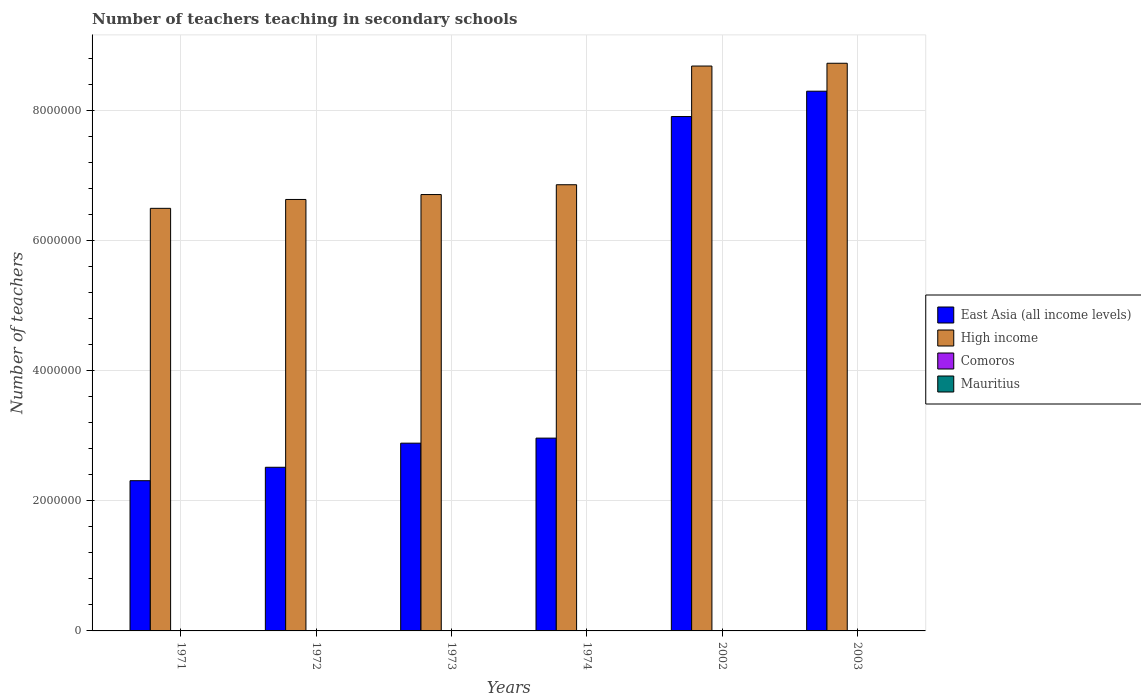How many different coloured bars are there?
Provide a succinct answer. 4. Are the number of bars per tick equal to the number of legend labels?
Give a very brief answer. Yes. Are the number of bars on each tick of the X-axis equal?
Offer a very short reply. Yes. How many bars are there on the 5th tick from the left?
Your answer should be compact. 4. How many bars are there on the 4th tick from the right?
Offer a terse response. 4. In how many cases, is the number of bars for a given year not equal to the number of legend labels?
Your response must be concise. 0. What is the number of teachers teaching in secondary schools in High income in 2002?
Give a very brief answer. 8.68e+06. Across all years, what is the maximum number of teachers teaching in secondary schools in East Asia (all income levels)?
Provide a short and direct response. 8.30e+06. Across all years, what is the minimum number of teachers teaching in secondary schools in High income?
Offer a very short reply. 6.49e+06. In which year was the number of teachers teaching in secondary schools in Comoros maximum?
Provide a succinct answer. 2003. In which year was the number of teachers teaching in secondary schools in East Asia (all income levels) minimum?
Keep it short and to the point. 1971. What is the total number of teachers teaching in secondary schools in Comoros in the graph?
Keep it short and to the point. 6367. What is the difference between the number of teachers teaching in secondary schools in Comoros in 1973 and that in 2002?
Offer a very short reply. -2485. What is the difference between the number of teachers teaching in secondary schools in High income in 1974 and the number of teachers teaching in secondary schools in Comoros in 2002?
Offer a very short reply. 6.85e+06. What is the average number of teachers teaching in secondary schools in High income per year?
Your answer should be compact. 7.35e+06. In the year 2002, what is the difference between the number of teachers teaching in secondary schools in East Asia (all income levels) and number of teachers teaching in secondary schools in High income?
Offer a very short reply. -7.76e+05. In how many years, is the number of teachers teaching in secondary schools in Mauritius greater than 2000000?
Provide a succinct answer. 0. What is the ratio of the number of teachers teaching in secondary schools in High income in 1972 to that in 1973?
Provide a succinct answer. 0.99. What is the difference between the highest and the second highest number of teachers teaching in secondary schools in East Asia (all income levels)?
Your answer should be very brief. 3.90e+05. What is the difference between the highest and the lowest number of teachers teaching in secondary schools in High income?
Offer a terse response. 2.23e+06. Is the sum of the number of teachers teaching in secondary schools in East Asia (all income levels) in 1972 and 2002 greater than the maximum number of teachers teaching in secondary schools in Mauritius across all years?
Give a very brief answer. Yes. What does the 2nd bar from the left in 1973 represents?
Ensure brevity in your answer.  High income. What does the 1st bar from the right in 2003 represents?
Keep it short and to the point. Mauritius. Is it the case that in every year, the sum of the number of teachers teaching in secondary schools in Mauritius and number of teachers teaching in secondary schools in High income is greater than the number of teachers teaching in secondary schools in East Asia (all income levels)?
Provide a succinct answer. Yes. Are all the bars in the graph horizontal?
Keep it short and to the point. No. How many years are there in the graph?
Give a very brief answer. 6. What is the difference between two consecutive major ticks on the Y-axis?
Give a very brief answer. 2.00e+06. Are the values on the major ticks of Y-axis written in scientific E-notation?
Give a very brief answer. No. Where does the legend appear in the graph?
Provide a short and direct response. Center right. How many legend labels are there?
Your answer should be compact. 4. What is the title of the graph?
Keep it short and to the point. Number of teachers teaching in secondary schools. What is the label or title of the X-axis?
Make the answer very short. Years. What is the label or title of the Y-axis?
Your answer should be compact. Number of teachers. What is the Number of teachers in East Asia (all income levels) in 1971?
Give a very brief answer. 2.31e+06. What is the Number of teachers in High income in 1971?
Your answer should be very brief. 6.49e+06. What is the Number of teachers in Comoros in 1971?
Keep it short and to the point. 63. What is the Number of teachers in Mauritius in 1971?
Offer a terse response. 1890. What is the Number of teachers in East Asia (all income levels) in 1972?
Provide a short and direct response. 2.52e+06. What is the Number of teachers in High income in 1972?
Your response must be concise. 6.63e+06. What is the Number of teachers of Comoros in 1972?
Make the answer very short. 66. What is the Number of teachers in Mauritius in 1972?
Your answer should be very brief. 1856. What is the Number of teachers in East Asia (all income levels) in 1973?
Your answer should be very brief. 2.89e+06. What is the Number of teachers in High income in 1973?
Make the answer very short. 6.71e+06. What is the Number of teachers of Comoros in 1973?
Offer a terse response. 113. What is the Number of teachers of Mauritius in 1973?
Your answer should be compact. 1990. What is the Number of teachers in East Asia (all income levels) in 1974?
Keep it short and to the point. 2.96e+06. What is the Number of teachers in High income in 1974?
Provide a succinct answer. 6.86e+06. What is the Number of teachers in Comoros in 1974?
Offer a very short reply. 128. What is the Number of teachers in Mauritius in 1974?
Offer a terse response. 2027. What is the Number of teachers in East Asia (all income levels) in 2002?
Offer a terse response. 7.91e+06. What is the Number of teachers in High income in 2002?
Give a very brief answer. 8.68e+06. What is the Number of teachers in Comoros in 2002?
Make the answer very short. 2598. What is the Number of teachers of Mauritius in 2002?
Give a very brief answer. 5933. What is the Number of teachers in East Asia (all income levels) in 2003?
Provide a short and direct response. 8.30e+06. What is the Number of teachers in High income in 2003?
Keep it short and to the point. 8.72e+06. What is the Number of teachers in Comoros in 2003?
Offer a terse response. 3399. What is the Number of teachers of Mauritius in 2003?
Provide a short and direct response. 6371. Across all years, what is the maximum Number of teachers of East Asia (all income levels)?
Give a very brief answer. 8.30e+06. Across all years, what is the maximum Number of teachers of High income?
Your answer should be compact. 8.72e+06. Across all years, what is the maximum Number of teachers in Comoros?
Offer a very short reply. 3399. Across all years, what is the maximum Number of teachers of Mauritius?
Offer a terse response. 6371. Across all years, what is the minimum Number of teachers of East Asia (all income levels)?
Offer a very short reply. 2.31e+06. Across all years, what is the minimum Number of teachers of High income?
Ensure brevity in your answer.  6.49e+06. Across all years, what is the minimum Number of teachers of Comoros?
Give a very brief answer. 63. Across all years, what is the minimum Number of teachers in Mauritius?
Your answer should be very brief. 1856. What is the total Number of teachers of East Asia (all income levels) in the graph?
Keep it short and to the point. 2.69e+07. What is the total Number of teachers in High income in the graph?
Ensure brevity in your answer.  4.41e+07. What is the total Number of teachers in Comoros in the graph?
Your response must be concise. 6367. What is the total Number of teachers of Mauritius in the graph?
Your response must be concise. 2.01e+04. What is the difference between the Number of teachers of East Asia (all income levels) in 1971 and that in 1972?
Your answer should be compact. -2.06e+05. What is the difference between the Number of teachers of High income in 1971 and that in 1972?
Offer a terse response. -1.37e+05. What is the difference between the Number of teachers of Mauritius in 1971 and that in 1972?
Ensure brevity in your answer.  34. What is the difference between the Number of teachers of East Asia (all income levels) in 1971 and that in 1973?
Ensure brevity in your answer.  -5.77e+05. What is the difference between the Number of teachers of High income in 1971 and that in 1973?
Offer a very short reply. -2.12e+05. What is the difference between the Number of teachers in Comoros in 1971 and that in 1973?
Your answer should be compact. -50. What is the difference between the Number of teachers of Mauritius in 1971 and that in 1973?
Offer a terse response. -100. What is the difference between the Number of teachers in East Asia (all income levels) in 1971 and that in 1974?
Provide a succinct answer. -6.54e+05. What is the difference between the Number of teachers of High income in 1971 and that in 1974?
Give a very brief answer. -3.63e+05. What is the difference between the Number of teachers of Comoros in 1971 and that in 1974?
Provide a short and direct response. -65. What is the difference between the Number of teachers in Mauritius in 1971 and that in 1974?
Your answer should be compact. -137. What is the difference between the Number of teachers of East Asia (all income levels) in 1971 and that in 2002?
Your response must be concise. -5.60e+06. What is the difference between the Number of teachers in High income in 1971 and that in 2002?
Your answer should be compact. -2.19e+06. What is the difference between the Number of teachers of Comoros in 1971 and that in 2002?
Ensure brevity in your answer.  -2535. What is the difference between the Number of teachers in Mauritius in 1971 and that in 2002?
Ensure brevity in your answer.  -4043. What is the difference between the Number of teachers of East Asia (all income levels) in 1971 and that in 2003?
Provide a short and direct response. -5.99e+06. What is the difference between the Number of teachers in High income in 1971 and that in 2003?
Provide a succinct answer. -2.23e+06. What is the difference between the Number of teachers in Comoros in 1971 and that in 2003?
Offer a very short reply. -3336. What is the difference between the Number of teachers in Mauritius in 1971 and that in 2003?
Offer a very short reply. -4481. What is the difference between the Number of teachers of East Asia (all income levels) in 1972 and that in 1973?
Your answer should be compact. -3.71e+05. What is the difference between the Number of teachers of High income in 1972 and that in 1973?
Offer a very short reply. -7.53e+04. What is the difference between the Number of teachers of Comoros in 1972 and that in 1973?
Provide a succinct answer. -47. What is the difference between the Number of teachers of Mauritius in 1972 and that in 1973?
Offer a very short reply. -134. What is the difference between the Number of teachers in East Asia (all income levels) in 1972 and that in 1974?
Provide a short and direct response. -4.48e+05. What is the difference between the Number of teachers of High income in 1972 and that in 1974?
Your response must be concise. -2.26e+05. What is the difference between the Number of teachers of Comoros in 1972 and that in 1974?
Your response must be concise. -62. What is the difference between the Number of teachers in Mauritius in 1972 and that in 1974?
Keep it short and to the point. -171. What is the difference between the Number of teachers in East Asia (all income levels) in 1972 and that in 2002?
Offer a terse response. -5.39e+06. What is the difference between the Number of teachers in High income in 1972 and that in 2002?
Make the answer very short. -2.05e+06. What is the difference between the Number of teachers in Comoros in 1972 and that in 2002?
Your answer should be compact. -2532. What is the difference between the Number of teachers of Mauritius in 1972 and that in 2002?
Your answer should be compact. -4077. What is the difference between the Number of teachers of East Asia (all income levels) in 1972 and that in 2003?
Provide a succinct answer. -5.78e+06. What is the difference between the Number of teachers in High income in 1972 and that in 2003?
Your answer should be compact. -2.09e+06. What is the difference between the Number of teachers of Comoros in 1972 and that in 2003?
Your response must be concise. -3333. What is the difference between the Number of teachers of Mauritius in 1972 and that in 2003?
Offer a very short reply. -4515. What is the difference between the Number of teachers of East Asia (all income levels) in 1973 and that in 1974?
Provide a succinct answer. -7.75e+04. What is the difference between the Number of teachers in High income in 1973 and that in 1974?
Give a very brief answer. -1.51e+05. What is the difference between the Number of teachers of Mauritius in 1973 and that in 1974?
Provide a succinct answer. -37. What is the difference between the Number of teachers in East Asia (all income levels) in 1973 and that in 2002?
Your answer should be compact. -5.02e+06. What is the difference between the Number of teachers in High income in 1973 and that in 2002?
Keep it short and to the point. -1.98e+06. What is the difference between the Number of teachers in Comoros in 1973 and that in 2002?
Offer a very short reply. -2485. What is the difference between the Number of teachers in Mauritius in 1973 and that in 2002?
Offer a very short reply. -3943. What is the difference between the Number of teachers in East Asia (all income levels) in 1973 and that in 2003?
Your response must be concise. -5.41e+06. What is the difference between the Number of teachers in High income in 1973 and that in 2003?
Provide a short and direct response. -2.02e+06. What is the difference between the Number of teachers of Comoros in 1973 and that in 2003?
Offer a terse response. -3286. What is the difference between the Number of teachers in Mauritius in 1973 and that in 2003?
Make the answer very short. -4381. What is the difference between the Number of teachers of East Asia (all income levels) in 1974 and that in 2002?
Offer a very short reply. -4.94e+06. What is the difference between the Number of teachers in High income in 1974 and that in 2002?
Your response must be concise. -1.82e+06. What is the difference between the Number of teachers of Comoros in 1974 and that in 2002?
Give a very brief answer. -2470. What is the difference between the Number of teachers in Mauritius in 1974 and that in 2002?
Make the answer very short. -3906. What is the difference between the Number of teachers of East Asia (all income levels) in 1974 and that in 2003?
Give a very brief answer. -5.33e+06. What is the difference between the Number of teachers in High income in 1974 and that in 2003?
Offer a terse response. -1.87e+06. What is the difference between the Number of teachers of Comoros in 1974 and that in 2003?
Ensure brevity in your answer.  -3271. What is the difference between the Number of teachers of Mauritius in 1974 and that in 2003?
Your answer should be compact. -4344. What is the difference between the Number of teachers of East Asia (all income levels) in 2002 and that in 2003?
Offer a terse response. -3.90e+05. What is the difference between the Number of teachers in High income in 2002 and that in 2003?
Give a very brief answer. -4.28e+04. What is the difference between the Number of teachers in Comoros in 2002 and that in 2003?
Your response must be concise. -801. What is the difference between the Number of teachers of Mauritius in 2002 and that in 2003?
Make the answer very short. -438. What is the difference between the Number of teachers of East Asia (all income levels) in 1971 and the Number of teachers of High income in 1972?
Provide a short and direct response. -4.32e+06. What is the difference between the Number of teachers in East Asia (all income levels) in 1971 and the Number of teachers in Comoros in 1972?
Your response must be concise. 2.31e+06. What is the difference between the Number of teachers of East Asia (all income levels) in 1971 and the Number of teachers of Mauritius in 1972?
Ensure brevity in your answer.  2.31e+06. What is the difference between the Number of teachers of High income in 1971 and the Number of teachers of Comoros in 1972?
Your answer should be very brief. 6.49e+06. What is the difference between the Number of teachers in High income in 1971 and the Number of teachers in Mauritius in 1972?
Your answer should be very brief. 6.49e+06. What is the difference between the Number of teachers of Comoros in 1971 and the Number of teachers of Mauritius in 1972?
Your response must be concise. -1793. What is the difference between the Number of teachers of East Asia (all income levels) in 1971 and the Number of teachers of High income in 1973?
Your answer should be very brief. -4.40e+06. What is the difference between the Number of teachers of East Asia (all income levels) in 1971 and the Number of teachers of Comoros in 1973?
Your response must be concise. 2.31e+06. What is the difference between the Number of teachers of East Asia (all income levels) in 1971 and the Number of teachers of Mauritius in 1973?
Give a very brief answer. 2.31e+06. What is the difference between the Number of teachers of High income in 1971 and the Number of teachers of Comoros in 1973?
Your answer should be very brief. 6.49e+06. What is the difference between the Number of teachers of High income in 1971 and the Number of teachers of Mauritius in 1973?
Offer a terse response. 6.49e+06. What is the difference between the Number of teachers of Comoros in 1971 and the Number of teachers of Mauritius in 1973?
Ensure brevity in your answer.  -1927. What is the difference between the Number of teachers of East Asia (all income levels) in 1971 and the Number of teachers of High income in 1974?
Your response must be concise. -4.55e+06. What is the difference between the Number of teachers of East Asia (all income levels) in 1971 and the Number of teachers of Comoros in 1974?
Provide a short and direct response. 2.31e+06. What is the difference between the Number of teachers of East Asia (all income levels) in 1971 and the Number of teachers of Mauritius in 1974?
Your answer should be compact. 2.31e+06. What is the difference between the Number of teachers in High income in 1971 and the Number of teachers in Comoros in 1974?
Your answer should be compact. 6.49e+06. What is the difference between the Number of teachers in High income in 1971 and the Number of teachers in Mauritius in 1974?
Make the answer very short. 6.49e+06. What is the difference between the Number of teachers in Comoros in 1971 and the Number of teachers in Mauritius in 1974?
Give a very brief answer. -1964. What is the difference between the Number of teachers of East Asia (all income levels) in 1971 and the Number of teachers of High income in 2002?
Ensure brevity in your answer.  -6.37e+06. What is the difference between the Number of teachers of East Asia (all income levels) in 1971 and the Number of teachers of Comoros in 2002?
Offer a terse response. 2.31e+06. What is the difference between the Number of teachers in East Asia (all income levels) in 1971 and the Number of teachers in Mauritius in 2002?
Keep it short and to the point. 2.30e+06. What is the difference between the Number of teachers in High income in 1971 and the Number of teachers in Comoros in 2002?
Your response must be concise. 6.49e+06. What is the difference between the Number of teachers in High income in 1971 and the Number of teachers in Mauritius in 2002?
Ensure brevity in your answer.  6.49e+06. What is the difference between the Number of teachers in Comoros in 1971 and the Number of teachers in Mauritius in 2002?
Keep it short and to the point. -5870. What is the difference between the Number of teachers of East Asia (all income levels) in 1971 and the Number of teachers of High income in 2003?
Provide a short and direct response. -6.42e+06. What is the difference between the Number of teachers in East Asia (all income levels) in 1971 and the Number of teachers in Comoros in 2003?
Provide a short and direct response. 2.31e+06. What is the difference between the Number of teachers in East Asia (all income levels) in 1971 and the Number of teachers in Mauritius in 2003?
Ensure brevity in your answer.  2.30e+06. What is the difference between the Number of teachers in High income in 1971 and the Number of teachers in Comoros in 2003?
Ensure brevity in your answer.  6.49e+06. What is the difference between the Number of teachers in High income in 1971 and the Number of teachers in Mauritius in 2003?
Offer a terse response. 6.49e+06. What is the difference between the Number of teachers in Comoros in 1971 and the Number of teachers in Mauritius in 2003?
Your answer should be compact. -6308. What is the difference between the Number of teachers of East Asia (all income levels) in 1972 and the Number of teachers of High income in 1973?
Your answer should be compact. -4.19e+06. What is the difference between the Number of teachers in East Asia (all income levels) in 1972 and the Number of teachers in Comoros in 1973?
Keep it short and to the point. 2.51e+06. What is the difference between the Number of teachers in East Asia (all income levels) in 1972 and the Number of teachers in Mauritius in 1973?
Keep it short and to the point. 2.51e+06. What is the difference between the Number of teachers of High income in 1972 and the Number of teachers of Comoros in 1973?
Provide a short and direct response. 6.63e+06. What is the difference between the Number of teachers of High income in 1972 and the Number of teachers of Mauritius in 1973?
Your answer should be very brief. 6.63e+06. What is the difference between the Number of teachers of Comoros in 1972 and the Number of teachers of Mauritius in 1973?
Your answer should be very brief. -1924. What is the difference between the Number of teachers in East Asia (all income levels) in 1972 and the Number of teachers in High income in 1974?
Keep it short and to the point. -4.34e+06. What is the difference between the Number of teachers of East Asia (all income levels) in 1972 and the Number of teachers of Comoros in 1974?
Provide a short and direct response. 2.51e+06. What is the difference between the Number of teachers of East Asia (all income levels) in 1972 and the Number of teachers of Mauritius in 1974?
Provide a short and direct response. 2.51e+06. What is the difference between the Number of teachers of High income in 1972 and the Number of teachers of Comoros in 1974?
Give a very brief answer. 6.63e+06. What is the difference between the Number of teachers in High income in 1972 and the Number of teachers in Mauritius in 1974?
Offer a terse response. 6.63e+06. What is the difference between the Number of teachers of Comoros in 1972 and the Number of teachers of Mauritius in 1974?
Your response must be concise. -1961. What is the difference between the Number of teachers of East Asia (all income levels) in 1972 and the Number of teachers of High income in 2002?
Keep it short and to the point. -6.17e+06. What is the difference between the Number of teachers of East Asia (all income levels) in 1972 and the Number of teachers of Comoros in 2002?
Give a very brief answer. 2.51e+06. What is the difference between the Number of teachers of East Asia (all income levels) in 1972 and the Number of teachers of Mauritius in 2002?
Your answer should be very brief. 2.51e+06. What is the difference between the Number of teachers in High income in 1972 and the Number of teachers in Comoros in 2002?
Give a very brief answer. 6.63e+06. What is the difference between the Number of teachers in High income in 1972 and the Number of teachers in Mauritius in 2002?
Keep it short and to the point. 6.63e+06. What is the difference between the Number of teachers in Comoros in 1972 and the Number of teachers in Mauritius in 2002?
Your answer should be very brief. -5867. What is the difference between the Number of teachers in East Asia (all income levels) in 1972 and the Number of teachers in High income in 2003?
Give a very brief answer. -6.21e+06. What is the difference between the Number of teachers of East Asia (all income levels) in 1972 and the Number of teachers of Comoros in 2003?
Your response must be concise. 2.51e+06. What is the difference between the Number of teachers in East Asia (all income levels) in 1972 and the Number of teachers in Mauritius in 2003?
Your response must be concise. 2.51e+06. What is the difference between the Number of teachers of High income in 1972 and the Number of teachers of Comoros in 2003?
Give a very brief answer. 6.63e+06. What is the difference between the Number of teachers of High income in 1972 and the Number of teachers of Mauritius in 2003?
Offer a very short reply. 6.62e+06. What is the difference between the Number of teachers of Comoros in 1972 and the Number of teachers of Mauritius in 2003?
Offer a very short reply. -6305. What is the difference between the Number of teachers of East Asia (all income levels) in 1973 and the Number of teachers of High income in 1974?
Make the answer very short. -3.97e+06. What is the difference between the Number of teachers of East Asia (all income levels) in 1973 and the Number of teachers of Comoros in 1974?
Provide a short and direct response. 2.89e+06. What is the difference between the Number of teachers in East Asia (all income levels) in 1973 and the Number of teachers in Mauritius in 1974?
Keep it short and to the point. 2.88e+06. What is the difference between the Number of teachers of High income in 1973 and the Number of teachers of Comoros in 1974?
Offer a terse response. 6.71e+06. What is the difference between the Number of teachers in High income in 1973 and the Number of teachers in Mauritius in 1974?
Ensure brevity in your answer.  6.70e+06. What is the difference between the Number of teachers in Comoros in 1973 and the Number of teachers in Mauritius in 1974?
Your response must be concise. -1914. What is the difference between the Number of teachers in East Asia (all income levels) in 1973 and the Number of teachers in High income in 2002?
Offer a terse response. -5.80e+06. What is the difference between the Number of teachers of East Asia (all income levels) in 1973 and the Number of teachers of Comoros in 2002?
Your response must be concise. 2.88e+06. What is the difference between the Number of teachers of East Asia (all income levels) in 1973 and the Number of teachers of Mauritius in 2002?
Keep it short and to the point. 2.88e+06. What is the difference between the Number of teachers of High income in 1973 and the Number of teachers of Comoros in 2002?
Provide a succinct answer. 6.70e+06. What is the difference between the Number of teachers of High income in 1973 and the Number of teachers of Mauritius in 2002?
Offer a terse response. 6.70e+06. What is the difference between the Number of teachers of Comoros in 1973 and the Number of teachers of Mauritius in 2002?
Ensure brevity in your answer.  -5820. What is the difference between the Number of teachers of East Asia (all income levels) in 1973 and the Number of teachers of High income in 2003?
Provide a succinct answer. -5.84e+06. What is the difference between the Number of teachers of East Asia (all income levels) in 1973 and the Number of teachers of Comoros in 2003?
Provide a short and direct response. 2.88e+06. What is the difference between the Number of teachers in East Asia (all income levels) in 1973 and the Number of teachers in Mauritius in 2003?
Offer a terse response. 2.88e+06. What is the difference between the Number of teachers of High income in 1973 and the Number of teachers of Comoros in 2003?
Make the answer very short. 6.70e+06. What is the difference between the Number of teachers of High income in 1973 and the Number of teachers of Mauritius in 2003?
Your answer should be compact. 6.70e+06. What is the difference between the Number of teachers in Comoros in 1973 and the Number of teachers in Mauritius in 2003?
Your response must be concise. -6258. What is the difference between the Number of teachers of East Asia (all income levels) in 1974 and the Number of teachers of High income in 2002?
Your response must be concise. -5.72e+06. What is the difference between the Number of teachers of East Asia (all income levels) in 1974 and the Number of teachers of Comoros in 2002?
Offer a very short reply. 2.96e+06. What is the difference between the Number of teachers in East Asia (all income levels) in 1974 and the Number of teachers in Mauritius in 2002?
Keep it short and to the point. 2.96e+06. What is the difference between the Number of teachers in High income in 1974 and the Number of teachers in Comoros in 2002?
Offer a terse response. 6.85e+06. What is the difference between the Number of teachers of High income in 1974 and the Number of teachers of Mauritius in 2002?
Make the answer very short. 6.85e+06. What is the difference between the Number of teachers in Comoros in 1974 and the Number of teachers in Mauritius in 2002?
Your answer should be very brief. -5805. What is the difference between the Number of teachers in East Asia (all income levels) in 1974 and the Number of teachers in High income in 2003?
Offer a very short reply. -5.76e+06. What is the difference between the Number of teachers of East Asia (all income levels) in 1974 and the Number of teachers of Comoros in 2003?
Ensure brevity in your answer.  2.96e+06. What is the difference between the Number of teachers of East Asia (all income levels) in 1974 and the Number of teachers of Mauritius in 2003?
Make the answer very short. 2.96e+06. What is the difference between the Number of teachers of High income in 1974 and the Number of teachers of Comoros in 2003?
Ensure brevity in your answer.  6.85e+06. What is the difference between the Number of teachers in High income in 1974 and the Number of teachers in Mauritius in 2003?
Ensure brevity in your answer.  6.85e+06. What is the difference between the Number of teachers in Comoros in 1974 and the Number of teachers in Mauritius in 2003?
Keep it short and to the point. -6243. What is the difference between the Number of teachers of East Asia (all income levels) in 2002 and the Number of teachers of High income in 2003?
Provide a succinct answer. -8.19e+05. What is the difference between the Number of teachers in East Asia (all income levels) in 2002 and the Number of teachers in Comoros in 2003?
Your response must be concise. 7.90e+06. What is the difference between the Number of teachers in East Asia (all income levels) in 2002 and the Number of teachers in Mauritius in 2003?
Your answer should be compact. 7.90e+06. What is the difference between the Number of teachers in High income in 2002 and the Number of teachers in Comoros in 2003?
Your answer should be compact. 8.68e+06. What is the difference between the Number of teachers of High income in 2002 and the Number of teachers of Mauritius in 2003?
Provide a succinct answer. 8.68e+06. What is the difference between the Number of teachers of Comoros in 2002 and the Number of teachers of Mauritius in 2003?
Offer a very short reply. -3773. What is the average Number of teachers in East Asia (all income levels) per year?
Ensure brevity in your answer.  4.48e+06. What is the average Number of teachers in High income per year?
Ensure brevity in your answer.  7.35e+06. What is the average Number of teachers in Comoros per year?
Your answer should be compact. 1061.17. What is the average Number of teachers in Mauritius per year?
Your response must be concise. 3344.5. In the year 1971, what is the difference between the Number of teachers in East Asia (all income levels) and Number of teachers in High income?
Make the answer very short. -4.19e+06. In the year 1971, what is the difference between the Number of teachers in East Asia (all income levels) and Number of teachers in Comoros?
Offer a very short reply. 2.31e+06. In the year 1971, what is the difference between the Number of teachers in East Asia (all income levels) and Number of teachers in Mauritius?
Give a very brief answer. 2.31e+06. In the year 1971, what is the difference between the Number of teachers of High income and Number of teachers of Comoros?
Give a very brief answer. 6.49e+06. In the year 1971, what is the difference between the Number of teachers of High income and Number of teachers of Mauritius?
Your answer should be compact. 6.49e+06. In the year 1971, what is the difference between the Number of teachers of Comoros and Number of teachers of Mauritius?
Your answer should be compact. -1827. In the year 1972, what is the difference between the Number of teachers of East Asia (all income levels) and Number of teachers of High income?
Provide a succinct answer. -4.12e+06. In the year 1972, what is the difference between the Number of teachers in East Asia (all income levels) and Number of teachers in Comoros?
Give a very brief answer. 2.51e+06. In the year 1972, what is the difference between the Number of teachers of East Asia (all income levels) and Number of teachers of Mauritius?
Offer a terse response. 2.51e+06. In the year 1972, what is the difference between the Number of teachers of High income and Number of teachers of Comoros?
Your response must be concise. 6.63e+06. In the year 1972, what is the difference between the Number of teachers of High income and Number of teachers of Mauritius?
Keep it short and to the point. 6.63e+06. In the year 1972, what is the difference between the Number of teachers in Comoros and Number of teachers in Mauritius?
Give a very brief answer. -1790. In the year 1973, what is the difference between the Number of teachers of East Asia (all income levels) and Number of teachers of High income?
Your answer should be very brief. -3.82e+06. In the year 1973, what is the difference between the Number of teachers of East Asia (all income levels) and Number of teachers of Comoros?
Ensure brevity in your answer.  2.89e+06. In the year 1973, what is the difference between the Number of teachers of East Asia (all income levels) and Number of teachers of Mauritius?
Offer a terse response. 2.88e+06. In the year 1973, what is the difference between the Number of teachers of High income and Number of teachers of Comoros?
Keep it short and to the point. 6.71e+06. In the year 1973, what is the difference between the Number of teachers in High income and Number of teachers in Mauritius?
Your answer should be very brief. 6.70e+06. In the year 1973, what is the difference between the Number of teachers of Comoros and Number of teachers of Mauritius?
Offer a terse response. -1877. In the year 1974, what is the difference between the Number of teachers of East Asia (all income levels) and Number of teachers of High income?
Your answer should be compact. -3.89e+06. In the year 1974, what is the difference between the Number of teachers of East Asia (all income levels) and Number of teachers of Comoros?
Offer a very short reply. 2.96e+06. In the year 1974, what is the difference between the Number of teachers in East Asia (all income levels) and Number of teachers in Mauritius?
Provide a short and direct response. 2.96e+06. In the year 1974, what is the difference between the Number of teachers of High income and Number of teachers of Comoros?
Offer a terse response. 6.86e+06. In the year 1974, what is the difference between the Number of teachers of High income and Number of teachers of Mauritius?
Give a very brief answer. 6.86e+06. In the year 1974, what is the difference between the Number of teachers of Comoros and Number of teachers of Mauritius?
Offer a terse response. -1899. In the year 2002, what is the difference between the Number of teachers in East Asia (all income levels) and Number of teachers in High income?
Ensure brevity in your answer.  -7.76e+05. In the year 2002, what is the difference between the Number of teachers of East Asia (all income levels) and Number of teachers of Comoros?
Offer a terse response. 7.90e+06. In the year 2002, what is the difference between the Number of teachers in East Asia (all income levels) and Number of teachers in Mauritius?
Give a very brief answer. 7.90e+06. In the year 2002, what is the difference between the Number of teachers of High income and Number of teachers of Comoros?
Keep it short and to the point. 8.68e+06. In the year 2002, what is the difference between the Number of teachers in High income and Number of teachers in Mauritius?
Ensure brevity in your answer.  8.68e+06. In the year 2002, what is the difference between the Number of teachers of Comoros and Number of teachers of Mauritius?
Provide a short and direct response. -3335. In the year 2003, what is the difference between the Number of teachers in East Asia (all income levels) and Number of teachers in High income?
Ensure brevity in your answer.  -4.29e+05. In the year 2003, what is the difference between the Number of teachers of East Asia (all income levels) and Number of teachers of Comoros?
Offer a terse response. 8.29e+06. In the year 2003, what is the difference between the Number of teachers of East Asia (all income levels) and Number of teachers of Mauritius?
Provide a succinct answer. 8.29e+06. In the year 2003, what is the difference between the Number of teachers in High income and Number of teachers in Comoros?
Offer a terse response. 8.72e+06. In the year 2003, what is the difference between the Number of teachers in High income and Number of teachers in Mauritius?
Your answer should be very brief. 8.72e+06. In the year 2003, what is the difference between the Number of teachers of Comoros and Number of teachers of Mauritius?
Your answer should be compact. -2972. What is the ratio of the Number of teachers in East Asia (all income levels) in 1971 to that in 1972?
Make the answer very short. 0.92. What is the ratio of the Number of teachers in High income in 1971 to that in 1972?
Your answer should be very brief. 0.98. What is the ratio of the Number of teachers of Comoros in 1971 to that in 1972?
Your answer should be very brief. 0.95. What is the ratio of the Number of teachers in Mauritius in 1971 to that in 1972?
Give a very brief answer. 1.02. What is the ratio of the Number of teachers of East Asia (all income levels) in 1971 to that in 1973?
Provide a short and direct response. 0.8. What is the ratio of the Number of teachers in High income in 1971 to that in 1973?
Provide a succinct answer. 0.97. What is the ratio of the Number of teachers in Comoros in 1971 to that in 1973?
Your answer should be compact. 0.56. What is the ratio of the Number of teachers of Mauritius in 1971 to that in 1973?
Give a very brief answer. 0.95. What is the ratio of the Number of teachers of East Asia (all income levels) in 1971 to that in 1974?
Provide a succinct answer. 0.78. What is the ratio of the Number of teachers in High income in 1971 to that in 1974?
Your answer should be compact. 0.95. What is the ratio of the Number of teachers in Comoros in 1971 to that in 1974?
Ensure brevity in your answer.  0.49. What is the ratio of the Number of teachers of Mauritius in 1971 to that in 1974?
Your answer should be very brief. 0.93. What is the ratio of the Number of teachers of East Asia (all income levels) in 1971 to that in 2002?
Provide a succinct answer. 0.29. What is the ratio of the Number of teachers in High income in 1971 to that in 2002?
Offer a terse response. 0.75. What is the ratio of the Number of teachers in Comoros in 1971 to that in 2002?
Your answer should be compact. 0.02. What is the ratio of the Number of teachers of Mauritius in 1971 to that in 2002?
Your answer should be compact. 0.32. What is the ratio of the Number of teachers of East Asia (all income levels) in 1971 to that in 2003?
Your response must be concise. 0.28. What is the ratio of the Number of teachers of High income in 1971 to that in 2003?
Ensure brevity in your answer.  0.74. What is the ratio of the Number of teachers of Comoros in 1971 to that in 2003?
Give a very brief answer. 0.02. What is the ratio of the Number of teachers of Mauritius in 1971 to that in 2003?
Offer a terse response. 0.3. What is the ratio of the Number of teachers of East Asia (all income levels) in 1972 to that in 1973?
Provide a short and direct response. 0.87. What is the ratio of the Number of teachers of Comoros in 1972 to that in 1973?
Give a very brief answer. 0.58. What is the ratio of the Number of teachers in Mauritius in 1972 to that in 1973?
Your answer should be compact. 0.93. What is the ratio of the Number of teachers in East Asia (all income levels) in 1972 to that in 1974?
Your answer should be compact. 0.85. What is the ratio of the Number of teachers in Comoros in 1972 to that in 1974?
Offer a terse response. 0.52. What is the ratio of the Number of teachers of Mauritius in 1972 to that in 1974?
Provide a succinct answer. 0.92. What is the ratio of the Number of teachers of East Asia (all income levels) in 1972 to that in 2002?
Your answer should be very brief. 0.32. What is the ratio of the Number of teachers of High income in 1972 to that in 2002?
Provide a succinct answer. 0.76. What is the ratio of the Number of teachers of Comoros in 1972 to that in 2002?
Your response must be concise. 0.03. What is the ratio of the Number of teachers of Mauritius in 1972 to that in 2002?
Give a very brief answer. 0.31. What is the ratio of the Number of teachers of East Asia (all income levels) in 1972 to that in 2003?
Give a very brief answer. 0.3. What is the ratio of the Number of teachers in High income in 1972 to that in 2003?
Provide a succinct answer. 0.76. What is the ratio of the Number of teachers of Comoros in 1972 to that in 2003?
Make the answer very short. 0.02. What is the ratio of the Number of teachers of Mauritius in 1972 to that in 2003?
Give a very brief answer. 0.29. What is the ratio of the Number of teachers of East Asia (all income levels) in 1973 to that in 1974?
Your answer should be very brief. 0.97. What is the ratio of the Number of teachers of Comoros in 1973 to that in 1974?
Offer a very short reply. 0.88. What is the ratio of the Number of teachers in Mauritius in 1973 to that in 1974?
Give a very brief answer. 0.98. What is the ratio of the Number of teachers of East Asia (all income levels) in 1973 to that in 2002?
Ensure brevity in your answer.  0.36. What is the ratio of the Number of teachers of High income in 1973 to that in 2002?
Keep it short and to the point. 0.77. What is the ratio of the Number of teachers in Comoros in 1973 to that in 2002?
Offer a very short reply. 0.04. What is the ratio of the Number of teachers of Mauritius in 1973 to that in 2002?
Your response must be concise. 0.34. What is the ratio of the Number of teachers of East Asia (all income levels) in 1973 to that in 2003?
Offer a terse response. 0.35. What is the ratio of the Number of teachers in High income in 1973 to that in 2003?
Your response must be concise. 0.77. What is the ratio of the Number of teachers of Comoros in 1973 to that in 2003?
Make the answer very short. 0.03. What is the ratio of the Number of teachers of Mauritius in 1973 to that in 2003?
Offer a very short reply. 0.31. What is the ratio of the Number of teachers of East Asia (all income levels) in 1974 to that in 2002?
Give a very brief answer. 0.37. What is the ratio of the Number of teachers in High income in 1974 to that in 2002?
Ensure brevity in your answer.  0.79. What is the ratio of the Number of teachers in Comoros in 1974 to that in 2002?
Ensure brevity in your answer.  0.05. What is the ratio of the Number of teachers in Mauritius in 1974 to that in 2002?
Your answer should be very brief. 0.34. What is the ratio of the Number of teachers of East Asia (all income levels) in 1974 to that in 2003?
Make the answer very short. 0.36. What is the ratio of the Number of teachers of High income in 1974 to that in 2003?
Give a very brief answer. 0.79. What is the ratio of the Number of teachers in Comoros in 1974 to that in 2003?
Offer a terse response. 0.04. What is the ratio of the Number of teachers in Mauritius in 1974 to that in 2003?
Give a very brief answer. 0.32. What is the ratio of the Number of teachers in East Asia (all income levels) in 2002 to that in 2003?
Make the answer very short. 0.95. What is the ratio of the Number of teachers in Comoros in 2002 to that in 2003?
Give a very brief answer. 0.76. What is the ratio of the Number of teachers in Mauritius in 2002 to that in 2003?
Your answer should be compact. 0.93. What is the difference between the highest and the second highest Number of teachers in East Asia (all income levels)?
Give a very brief answer. 3.90e+05. What is the difference between the highest and the second highest Number of teachers in High income?
Offer a very short reply. 4.28e+04. What is the difference between the highest and the second highest Number of teachers in Comoros?
Offer a terse response. 801. What is the difference between the highest and the second highest Number of teachers of Mauritius?
Your answer should be compact. 438. What is the difference between the highest and the lowest Number of teachers of East Asia (all income levels)?
Give a very brief answer. 5.99e+06. What is the difference between the highest and the lowest Number of teachers in High income?
Offer a very short reply. 2.23e+06. What is the difference between the highest and the lowest Number of teachers in Comoros?
Offer a very short reply. 3336. What is the difference between the highest and the lowest Number of teachers in Mauritius?
Keep it short and to the point. 4515. 